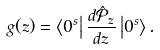<formula> <loc_0><loc_0><loc_500><loc_500>g ( z ) = \left \langle 0 ^ { s } \right | \frac { d \mathcal { \hat { P } } _ { z } } { d z } \left | 0 ^ { s } \right \rangle .</formula> 